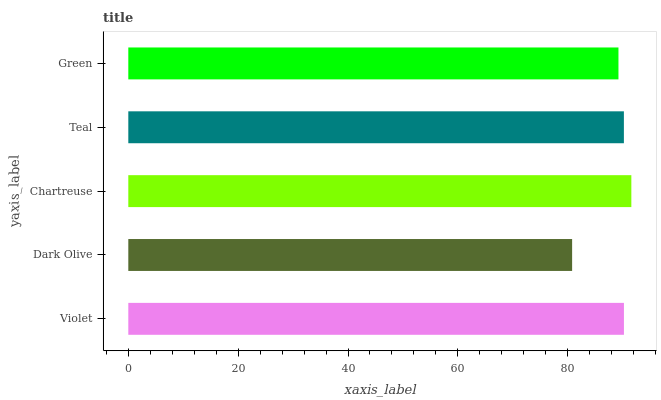Is Dark Olive the minimum?
Answer yes or no. Yes. Is Chartreuse the maximum?
Answer yes or no. Yes. Is Chartreuse the minimum?
Answer yes or no. No. Is Dark Olive the maximum?
Answer yes or no. No. Is Chartreuse greater than Dark Olive?
Answer yes or no. Yes. Is Dark Olive less than Chartreuse?
Answer yes or no. Yes. Is Dark Olive greater than Chartreuse?
Answer yes or no. No. Is Chartreuse less than Dark Olive?
Answer yes or no. No. Is Teal the high median?
Answer yes or no. Yes. Is Teal the low median?
Answer yes or no. Yes. Is Dark Olive the high median?
Answer yes or no. No. Is Chartreuse the low median?
Answer yes or no. No. 